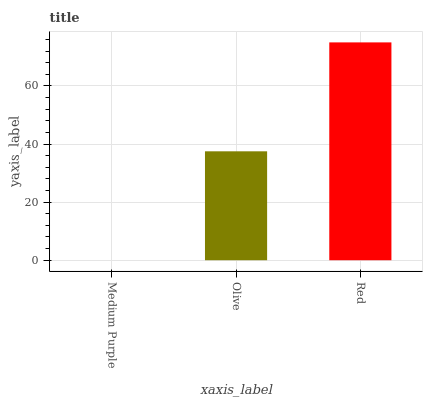Is Olive the minimum?
Answer yes or no. No. Is Olive the maximum?
Answer yes or no. No. Is Olive greater than Medium Purple?
Answer yes or no. Yes. Is Medium Purple less than Olive?
Answer yes or no. Yes. Is Medium Purple greater than Olive?
Answer yes or no. No. Is Olive less than Medium Purple?
Answer yes or no. No. Is Olive the high median?
Answer yes or no. Yes. Is Olive the low median?
Answer yes or no. Yes. Is Medium Purple the high median?
Answer yes or no. No. Is Red the low median?
Answer yes or no. No. 